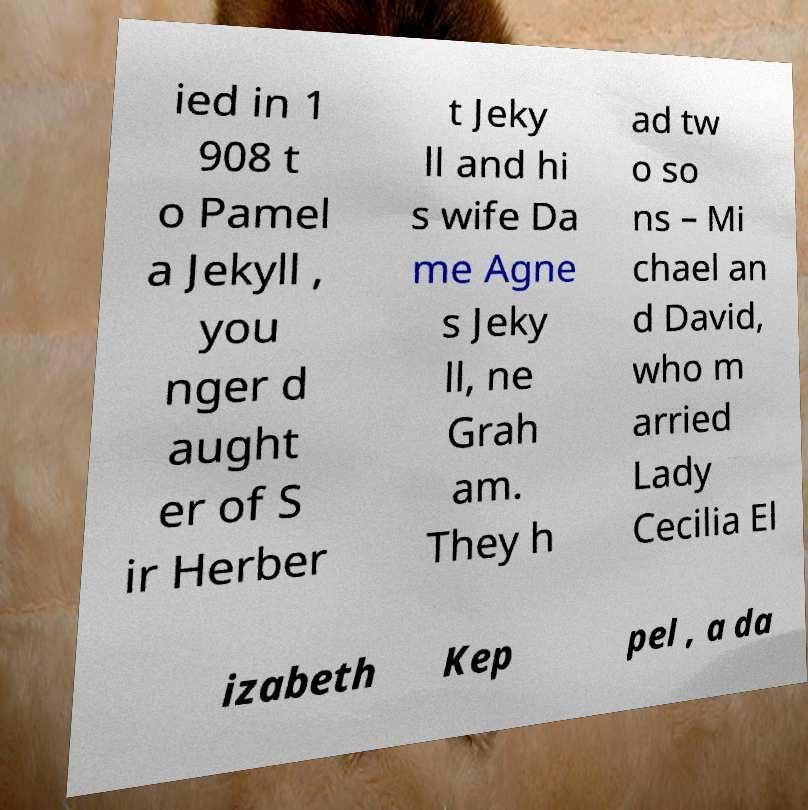I need the written content from this picture converted into text. Can you do that? ied in 1 908 t o Pamel a Jekyll , you nger d aught er of S ir Herber t Jeky ll and hi s wife Da me Agne s Jeky ll, ne Grah am. They h ad tw o so ns – Mi chael an d David, who m arried Lady Cecilia El izabeth Kep pel , a da 